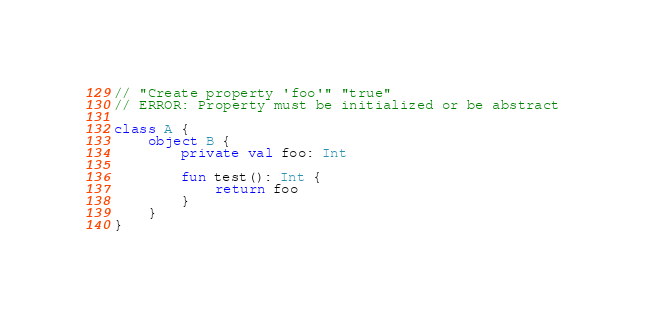<code> <loc_0><loc_0><loc_500><loc_500><_Kotlin_>// "Create property 'foo'" "true"
// ERROR: Property must be initialized or be abstract

class A {
    object B {
        private val foo: Int

        fun test(): Int {
            return foo
        }
    }
}
</code> 